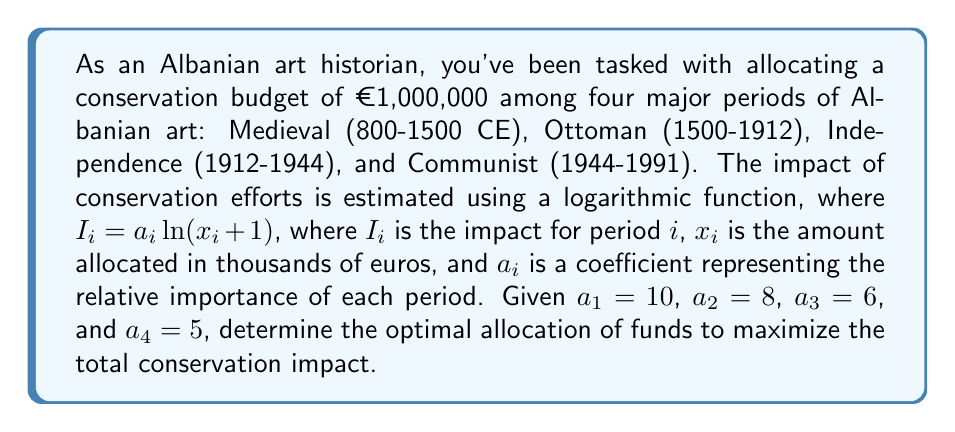Can you solve this math problem? To solve this resource allocation problem, we'll use the method of Lagrange multipliers. The objective is to maximize the total impact subject to the budget constraint.

1) First, let's define our objective function:
   $$f(x_1, x_2, x_3, x_4) = 10\ln(x_1 + 1) + 8\ln(x_2 + 1) + 6\ln(x_3 + 1) + 5\ln(x_4 + 1)$$

2) The constraint is:
   $$g(x_1, x_2, x_3, x_4) = x_1 + x_2 + x_3 + x_4 - 1000 = 0$$

3) We form the Lagrangian:
   $$L(x_1, x_2, x_3, x_4, \lambda) = f(x_1, x_2, x_3, x_4) - \lambda g(x_1, x_2, x_3, x_4)$$

4) Taking partial derivatives and setting them to zero:
   $$\frac{\partial L}{\partial x_1} = \frac{10}{x_1 + 1} - \lambda = 0$$
   $$\frac{\partial L}{\partial x_2} = \frac{8}{x_2 + 1} - \lambda = 0$$
   $$\frac{\partial L}{\partial x_3} = \frac{6}{x_3 + 1} - \lambda = 0$$
   $$\frac{\partial L}{\partial x_4} = \frac{5}{x_4 + 1} - \lambda = 0$$
   $$\frac{\partial L}{\partial \lambda} = x_1 + x_2 + x_3 + x_4 - 1000 = 0$$

5) From these equations, we can deduce:
   $$x_1 + 1 = \frac{10}{\lambda}$$
   $$x_2 + 1 = \frac{8}{\lambda}$$
   $$x_3 + 1 = \frac{6}{\lambda}$$
   $$x_4 + 1 = \frac{5}{\lambda}$$

6) Substituting these into the constraint equation:
   $$(\frac{10}{\lambda} - 1) + (\frac{8}{\lambda} - 1) + (\frac{6}{\lambda} - 1) + (\frac{5}{\lambda} - 1) = 1000$$
   $$\frac{29}{\lambda} - 4 = 1000$$
   $$\frac{29}{\lambda} = 1004$$
   $$\lambda = \frac{29}{1004} \approx 0.0289$$

7) Now we can solve for each $x_i$:
   $$x_1 = \frac{10}{0.0289} - 1 \approx 345.67$$
   $$x_2 = \frac{8}{0.0289} - 1 \approx 276.54$$
   $$x_3 = \frac{6}{0.0289} - 1 \approx 207.41$$
   $$x_4 = \frac{5}{0.0289} - 1 \approx 172.84$$

8) Rounding to the nearest thousand euros:
   $$x_1 \approx 346,000$$
   $$x_2 \approx 277,000$$
   $$x_3 \approx 207,000$$
   $$x_4 \approx 173,000$$
Answer: The optimal allocation of the conservation budget is approximately:
Medieval period (800-1500 CE): €346,000
Ottoman period (1500-1912): €277,000
Independence period (1912-1944): €207,000
Communist period (1944-1991): €173,000 